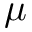<formula> <loc_0><loc_0><loc_500><loc_500>\mu</formula> 